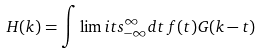<formula> <loc_0><loc_0><loc_500><loc_500>H ( k ) = \int \lim i t s _ { - \infty } ^ { \infty } d t \, f ( t ) G ( k - t )</formula> 